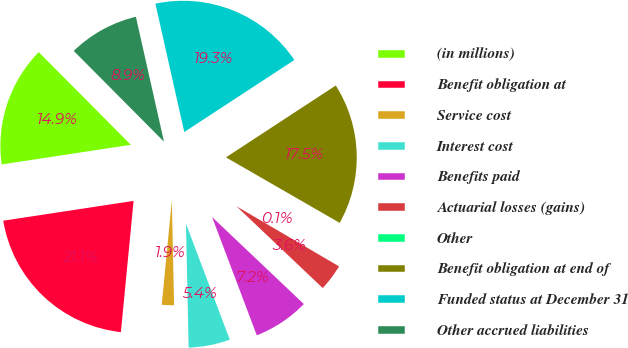Convert chart to OTSL. <chart><loc_0><loc_0><loc_500><loc_500><pie_chart><fcel>(in millions)<fcel>Benefit obligation at<fcel>Service cost<fcel>Interest cost<fcel>Benefits paid<fcel>Actuarial losses (gains)<fcel>Other<fcel>Benefit obligation at end of<fcel>Funded status at December 31<fcel>Other accrued liabilities<nl><fcel>14.95%<fcel>21.06%<fcel>1.88%<fcel>5.41%<fcel>7.17%<fcel>3.64%<fcel>0.12%<fcel>17.54%<fcel>19.3%<fcel>8.93%<nl></chart> 